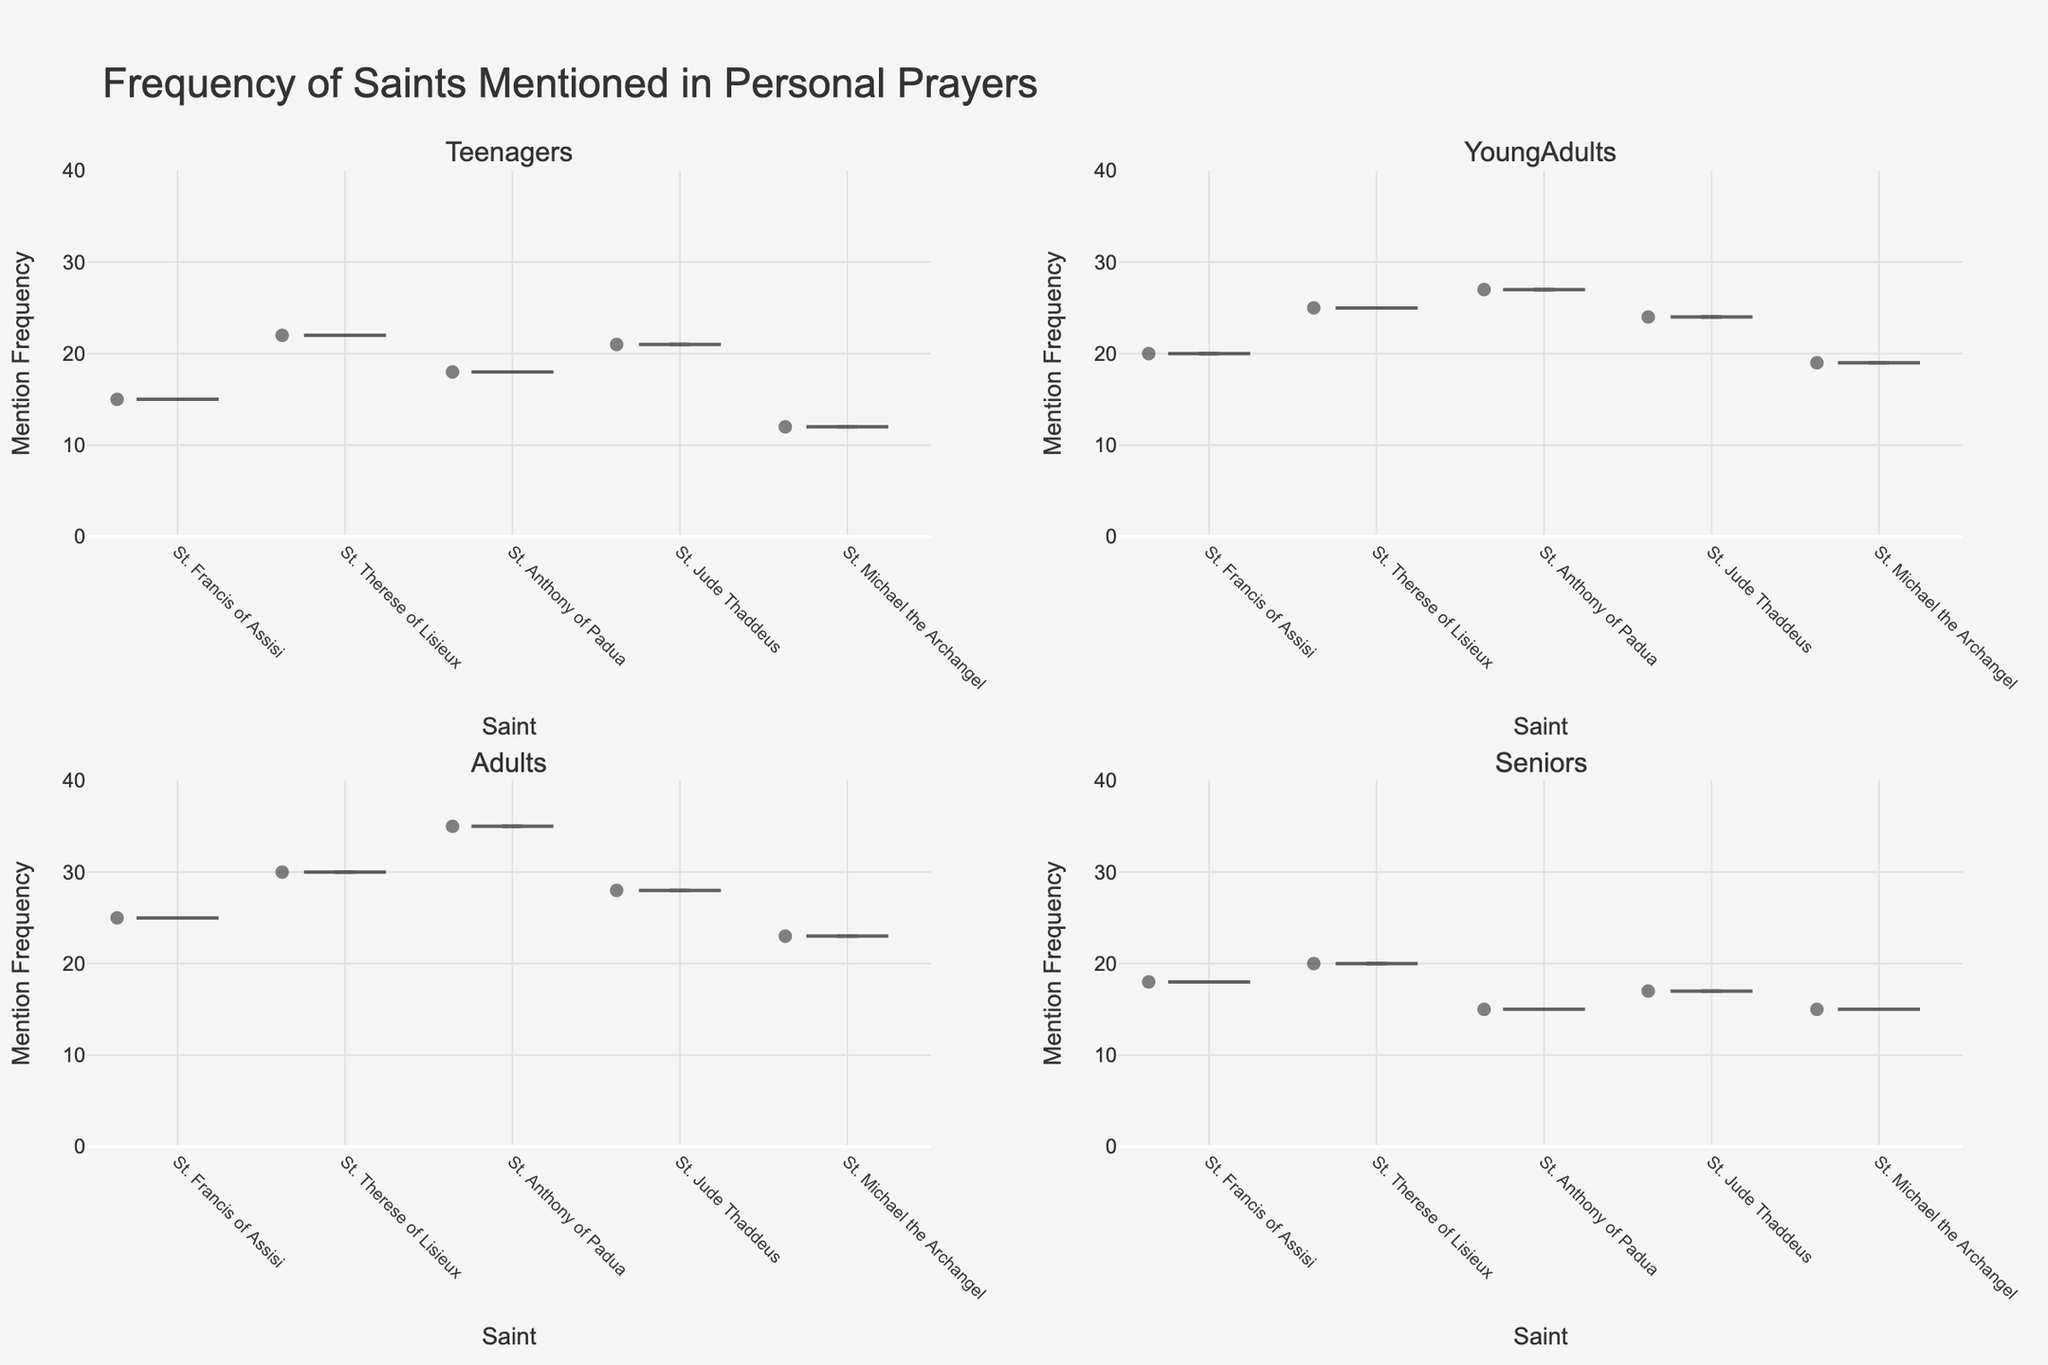What's the title of the figure? The title is typically found at the top of the figure. In this case, it is clearly marked. The title reads: "Frequency of Saints Mentioned in Personal Prayers"
Answer: Frequency of Saints Mentioned in Personal Prayers Which demographic group mentions St. Anthony of Padua the most? By examining the violin plots for each demographic group, one can observe the median lines and overall distribution. The highest concentration of mentions for St. Anthony of Padua is seen in the Adults group.
Answer: Adults Based on the plot, what is the overall range of mention frequencies for all groups? The range can be estimated by looking at the y-axis, which shows the frequency of mentions. The plot ranges from a minimum of 0 to a maximum frequency plus a few units above the highest value in the data. Here it appears to be from 0 to roughly 40.
Answer: 0 to 40 What is the median frequency of mentions for St. Therese of Lisieux among Young Adults? The median frequency in a violin plot is often represented by a line or a dot within the plot area. For Young Adults, examining the St. Therese of Lisieux plot shows a median line at 25.
Answer: 25 How does the mention frequency of St. Jude Thaddeus among Seniors compare to that among Teenagers? To compare, we look at the median lines or the overall distribution in the respective plots for St. Jude Thaddeus. The frequency is generally higher among Teenagers (median around 21) compared to Seniors (median around 17).
Answer: Teenagers have a higher frequency What is the mean frequency of mentions for St. Michael the Archangel among Adults? The mean frequency is indicated by a line within the violin plot. For Adults mentioning St. Michael the Archangel, the mean line is at about 23.
Answer: 23 Can you identify which saint has the most diverse range of mention frequencies among all demographic groups? The diversity or range of mention frequencies is depicted by the spread of the violin plot. St. Anthony of Padua's plots show the widest spans, especially among Adults, indicating a high diversity in mention frequencies.
Answer: St. Anthony of Padua Which demographic group has the lowest median mention frequency for St. Francis of Assisi? By observing the median lines across different groups for St. Francis of Assisi, the lowest median is seen in the Seniors demographic group.
Answer: Seniors What is the average frequency of mentions for St. Jude Thaddeus across all demographic groups? To calculate the average, one must sum the mentions across all groups and then divide by the number of groups: (21 (Teenagers) + 24 (Young Adults) + 28 (Adults) + 17 (Seniors))/4 = 22.5
Answer: 22.5 Among the Teenagers, which saint has the lowest mention frequency and what is it? For Teenagers, the saint with the lowest mention frequency can be noted directly from the heights of the violin plots. St. Michael the Archangel has the lowest frequency at 12.
Answer: St. Michael the Archangel, 12 